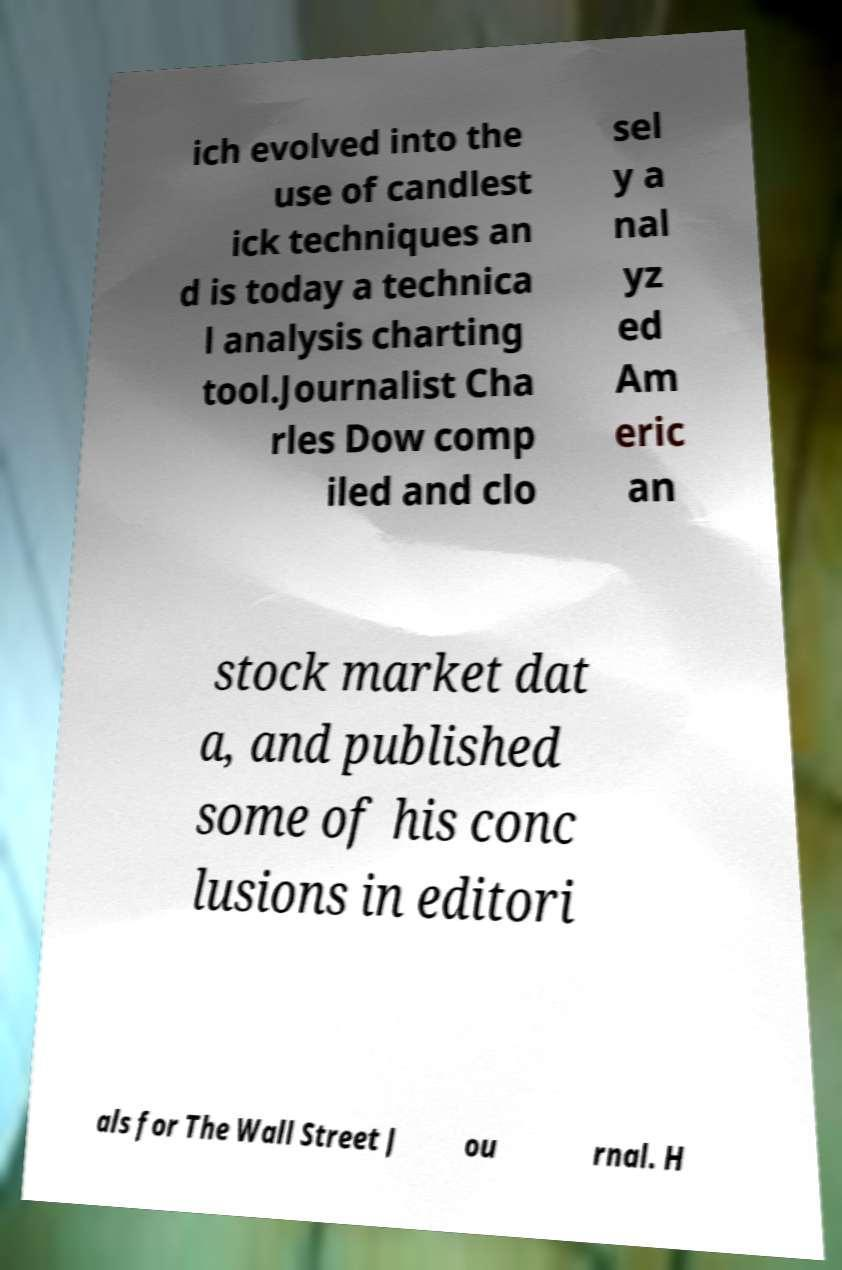Please identify and transcribe the text found in this image. ich evolved into the use of candlest ick techniques an d is today a technica l analysis charting tool.Journalist Cha rles Dow comp iled and clo sel y a nal yz ed Am eric an stock market dat a, and published some of his conc lusions in editori als for The Wall Street J ou rnal. H 